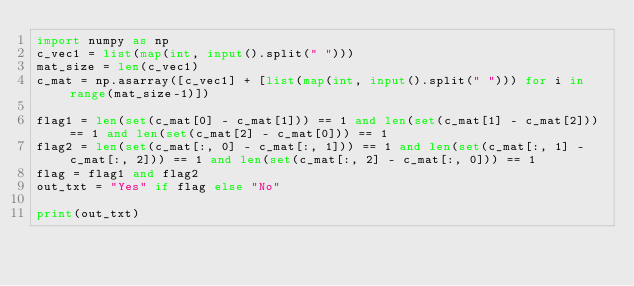<code> <loc_0><loc_0><loc_500><loc_500><_Python_>import numpy as np
c_vec1 = list(map(int, input().split(" ")))
mat_size = len(c_vec1)
c_mat = np.asarray([c_vec1] + [list(map(int, input().split(" "))) for i in range(mat_size-1)])

flag1 = len(set(c_mat[0] - c_mat[1])) == 1 and len(set(c_mat[1] - c_mat[2])) == 1 and len(set(c_mat[2] - c_mat[0])) == 1
flag2 = len(set(c_mat[:, 0] - c_mat[:, 1])) == 1 and len(set(c_mat[:, 1] - c_mat[:, 2])) == 1 and len(set(c_mat[:, 2] - c_mat[:, 0])) == 1
flag = flag1 and flag2
out_txt = "Yes" if flag else "No"

print(out_txt)</code> 